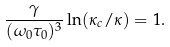<formula> <loc_0><loc_0><loc_500><loc_500>\frac { \gamma } { ( \omega _ { 0 } \tau _ { 0 } ) ^ { 3 } } \ln ( \kappa _ { c } / \kappa ) = 1 .</formula> 